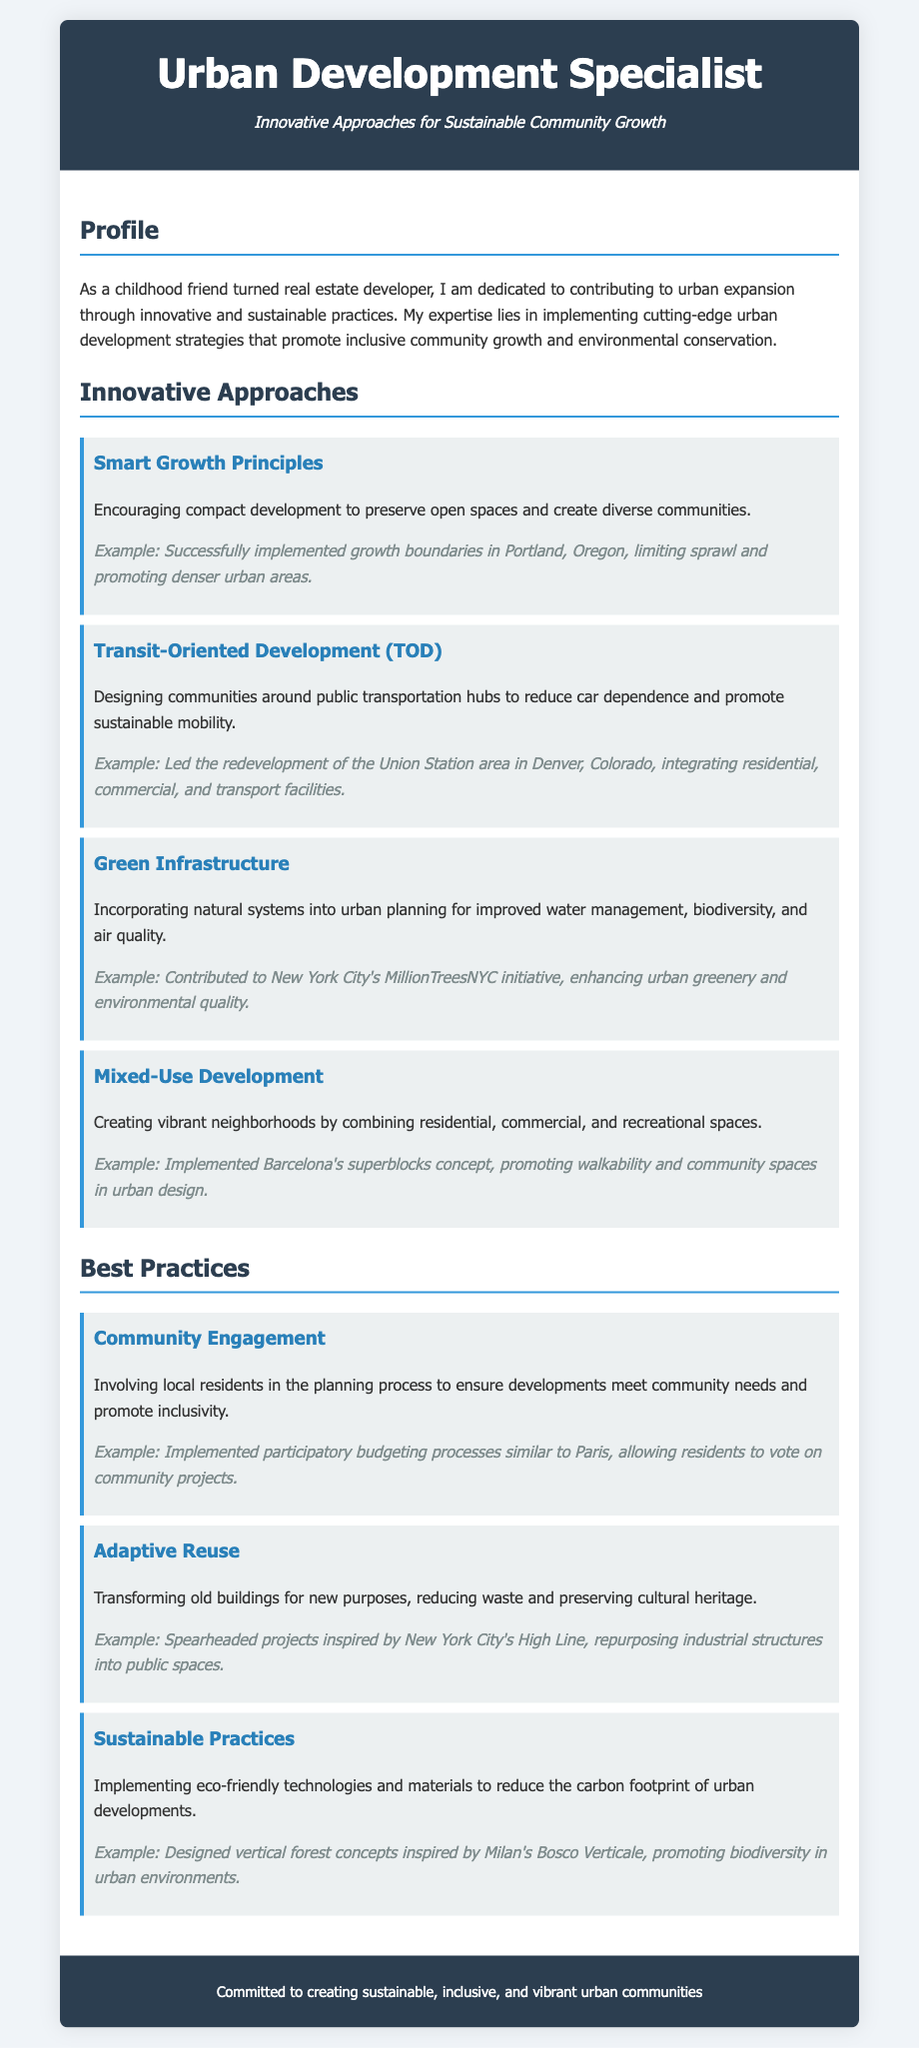what is the title of the document? The title of the document, as indicated in the header, is "Urban Development Specialist CV."
Answer: Urban Development Specialist CV who is the author of this CV? The CV indicates that the author is a "childhood friend turned real estate developer."
Answer: childhood friend turned real estate developer what is one of the innovative approaches mentioned? The document lists several innovative approaches, one of which is "Transit-Oriented Development (TOD)."
Answer: Transit-Oriented Development (TOD) in which city was an example of green infrastructure implemented? The document provides an example of green infrastructure implemented in New York City related to the MillionTreesNYC initiative.
Answer: New York City what does "mixed-use development" aim to create? The document states that mixed-use development aims to create vibrant neighborhoods by combining different types of spaces.
Answer: vibrant neighborhoods what is the purpose of community engagement in urban development? According to the document, community engagement is aimed at ensuring developments meet community needs and promote inclusivity.
Answer: ensuring developments meet community needs how many innovative approaches are listed in the CV? The document lists four innovative approaches under the section "Innovative Approaches."
Answer: four what does "adaptive reuse" involve? The document explains that adaptive reuse involves transforming old buildings for new purposes.
Answer: transforming old buildings for new purposes what is a key commitment stated in the footer? The footer mentions a commitment to creating sustainable, inclusive, and vibrant urban communities.
Answer: sustainable, inclusive, and vibrant urban communities 